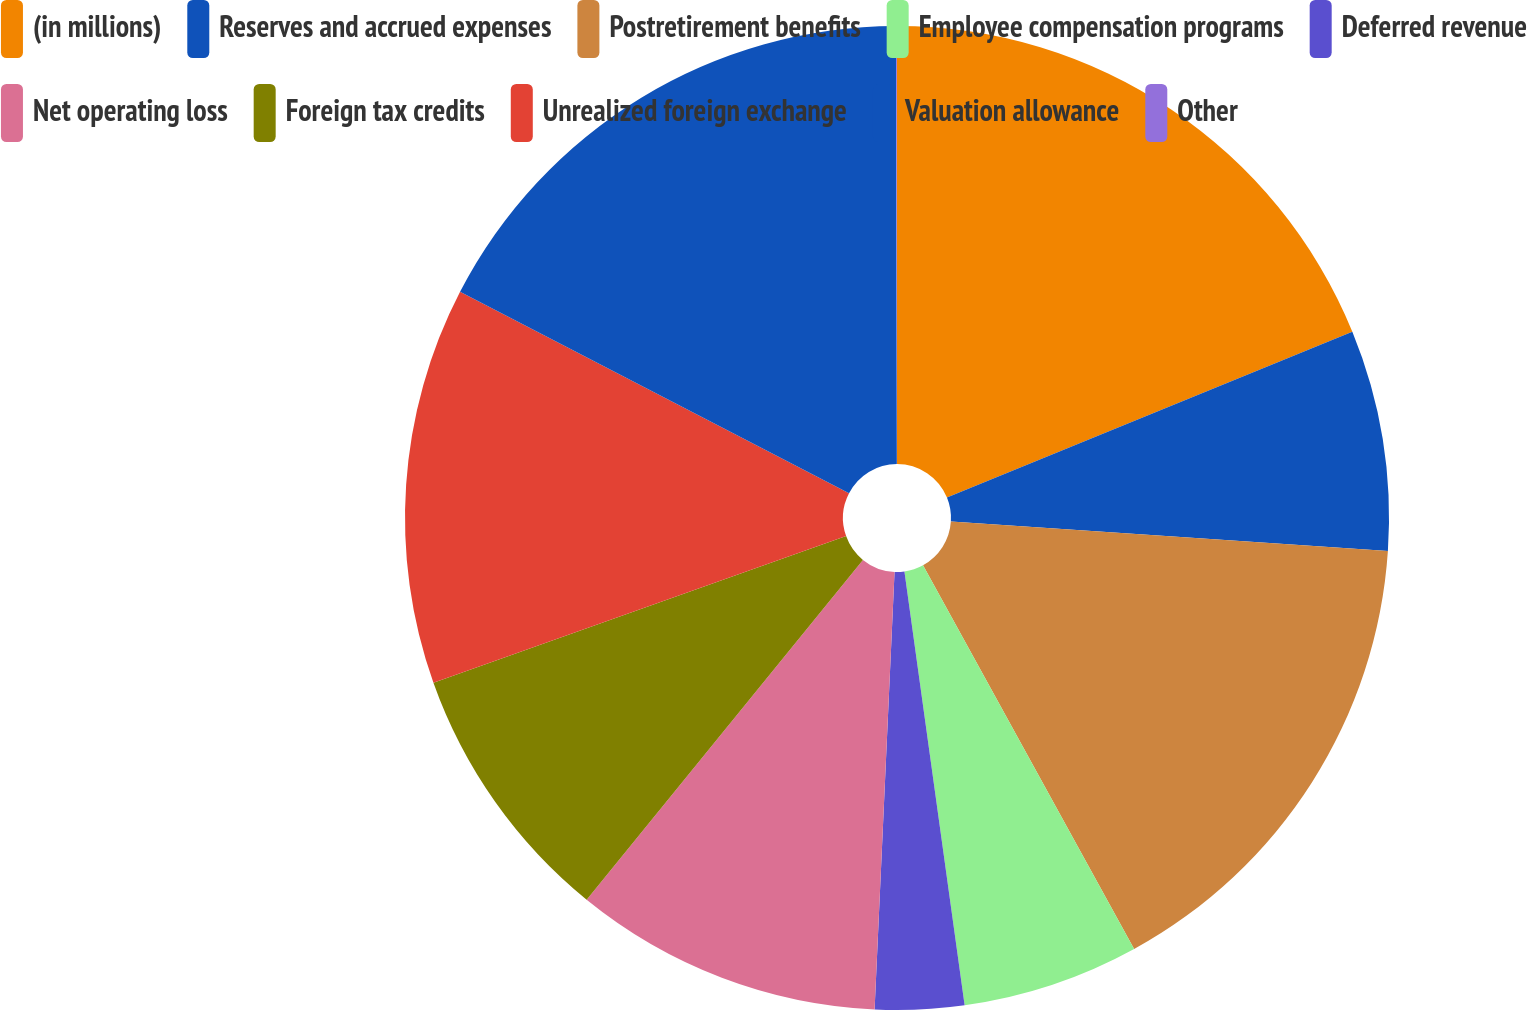Convert chart to OTSL. <chart><loc_0><loc_0><loc_500><loc_500><pie_chart><fcel>(in millions)<fcel>Reserves and accrued expenses<fcel>Postretirement benefits<fcel>Employee compensation programs<fcel>Deferred revenue<fcel>Net operating loss<fcel>Foreign tax credits<fcel>Unrealized foreign exchange<fcel>Valuation allowance<fcel>Other<nl><fcel>18.82%<fcel>7.25%<fcel>15.93%<fcel>5.81%<fcel>2.92%<fcel>10.14%<fcel>8.7%<fcel>13.04%<fcel>17.37%<fcel>0.03%<nl></chart> 